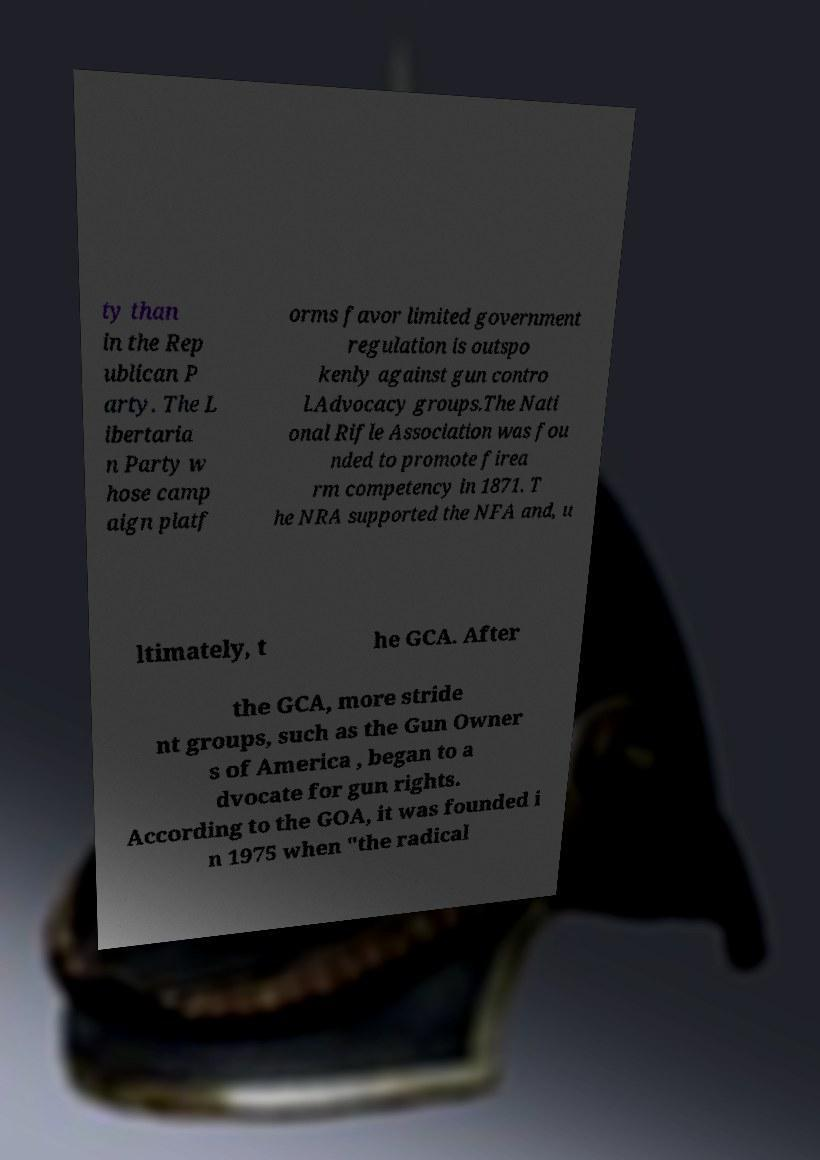Please read and relay the text visible in this image. What does it say? ty than in the Rep ublican P arty. The L ibertaria n Party w hose camp aign platf orms favor limited government regulation is outspo kenly against gun contro l.Advocacy groups.The Nati onal Rifle Association was fou nded to promote firea rm competency in 1871. T he NRA supported the NFA and, u ltimately, t he GCA. After the GCA, more stride nt groups, such as the Gun Owner s of America , began to a dvocate for gun rights. According to the GOA, it was founded i n 1975 when "the radical 